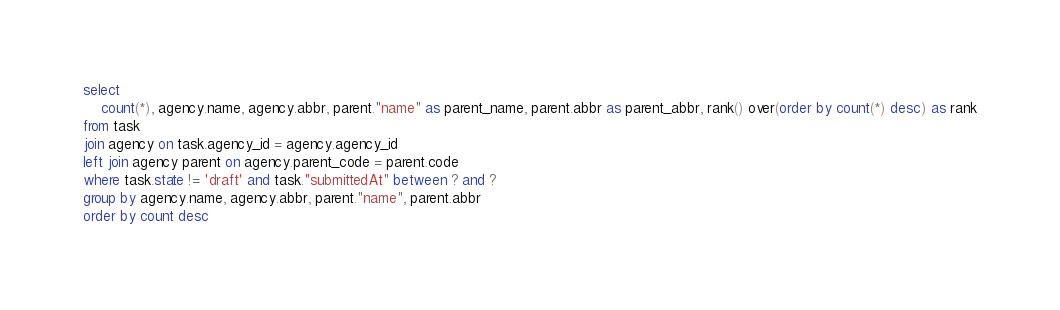Convert code to text. <code><loc_0><loc_0><loc_500><loc_500><_SQL_>select
	count(*), agency.name, agency.abbr, parent."name" as parent_name, parent.abbr as parent_abbr, rank() over(order by count(*) desc) as rank
from task
join agency on task.agency_id = agency.agency_id
left join agency parent on agency.parent_code = parent.code
where task.state != 'draft' and task."submittedAt" between ? and ?
group by agency.name, agency.abbr, parent."name", parent.abbr
order by count desc</code> 